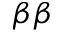<formula> <loc_0><loc_0><loc_500><loc_500>\beta \beta</formula> 